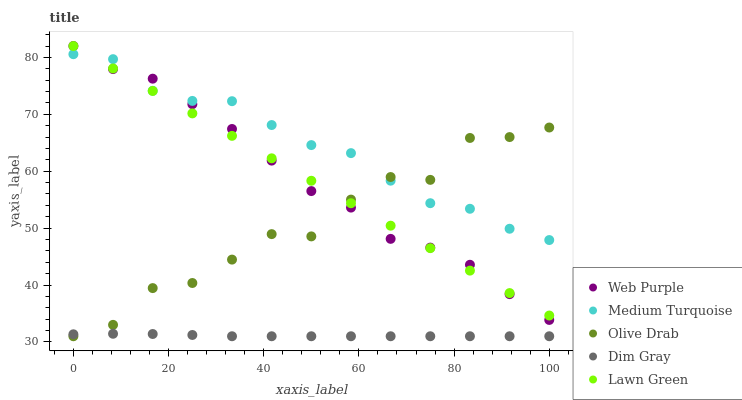Does Dim Gray have the minimum area under the curve?
Answer yes or no. Yes. Does Medium Turquoise have the maximum area under the curve?
Answer yes or no. Yes. Does Web Purple have the minimum area under the curve?
Answer yes or no. No. Does Web Purple have the maximum area under the curve?
Answer yes or no. No. Is Lawn Green the smoothest?
Answer yes or no. Yes. Is Olive Drab the roughest?
Answer yes or no. Yes. Is Web Purple the smoothest?
Answer yes or no. No. Is Web Purple the roughest?
Answer yes or no. No. Does Dim Gray have the lowest value?
Answer yes or no. Yes. Does Web Purple have the lowest value?
Answer yes or no. No. Does Web Purple have the highest value?
Answer yes or no. Yes. Does Dim Gray have the highest value?
Answer yes or no. No. Is Dim Gray less than Medium Turquoise?
Answer yes or no. Yes. Is Lawn Green greater than Dim Gray?
Answer yes or no. Yes. Does Dim Gray intersect Olive Drab?
Answer yes or no. Yes. Is Dim Gray less than Olive Drab?
Answer yes or no. No. Is Dim Gray greater than Olive Drab?
Answer yes or no. No. Does Dim Gray intersect Medium Turquoise?
Answer yes or no. No. 